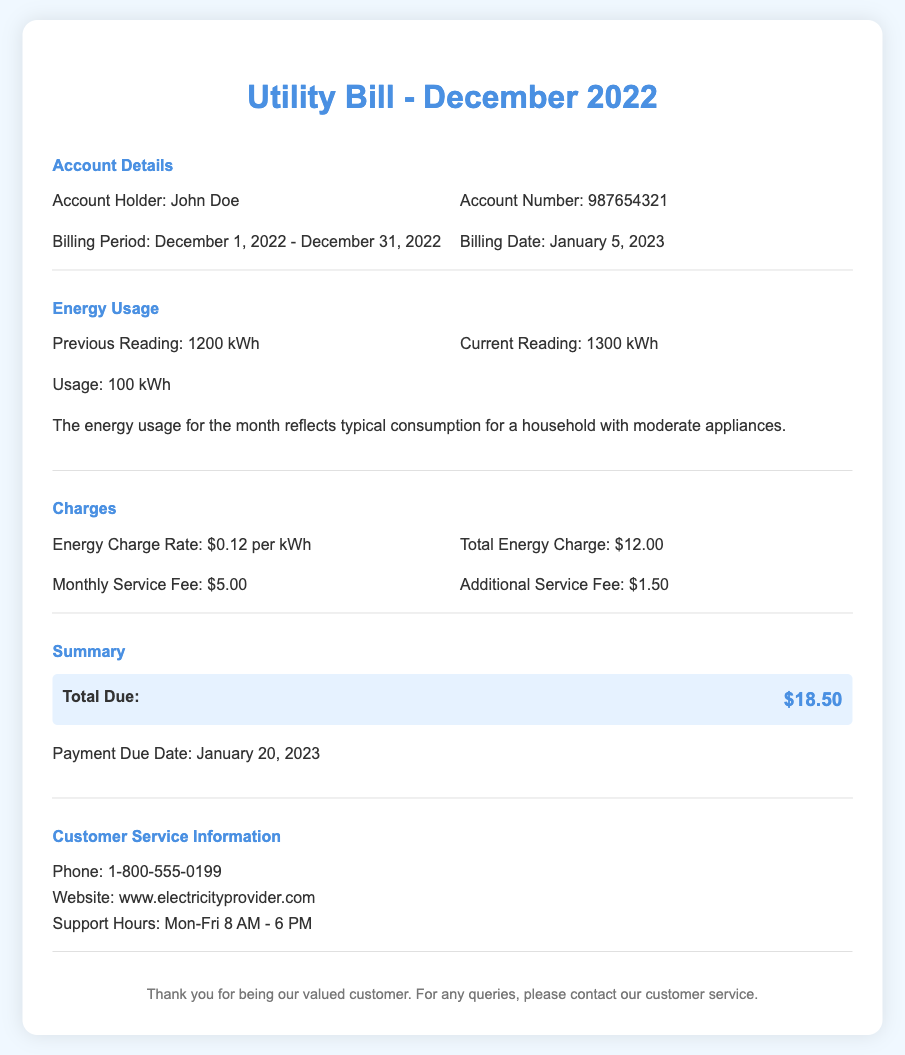What is the account holder's name? The account holder's name is listed in the account details section of the document.
Answer: John Doe What was the billing date? The billing date is specified in the account details section.
Answer: January 5, 2023 How much energy was used during December 2022? The energy usage indicates the difference between the current and previous reading, providing the total usage.
Answer: 100 kWh What is the energy charge rate per kWh? The document specifies the charge rate in the charges section.
Answer: $0.12 per kWh What is the total amount due? The total amount due is summarized in the summary section of the document.
Answer: $18.50 What is the monthly service fee? The monthly service fee is detailed under charges in the document.
Answer: $5.00 What is the payment due date? The payment due date is mentioned in the summary section.
Answer: January 20, 2023 What is the phone number for customer service? The customer service phone number is provided in the customer service information section.
Answer: 1-800-555-0199 How much is the additional service fee? The additional service fee is explicitly mentioned in the charges section.
Answer: $1.50 